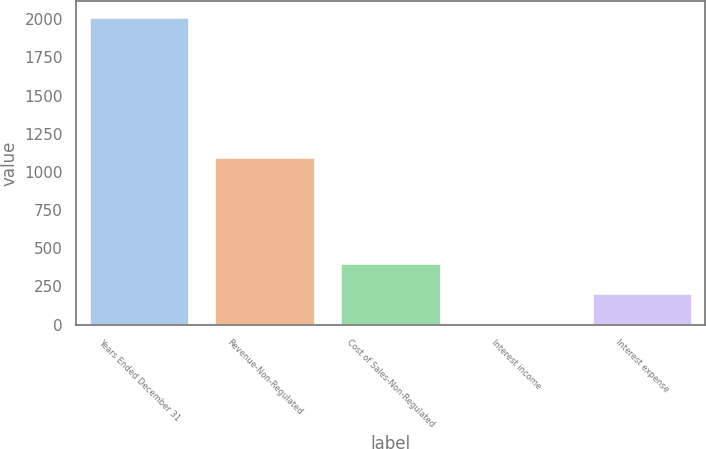Convert chart. <chart><loc_0><loc_0><loc_500><loc_500><bar_chart><fcel>Years Ended December 31<fcel>Revenue-Non-Regulated<fcel>Cost of Sales-Non-Regulated<fcel>Interest income<fcel>Interest expense<nl><fcel>2016<fcel>1100<fcel>406.4<fcel>4<fcel>205.2<nl></chart> 